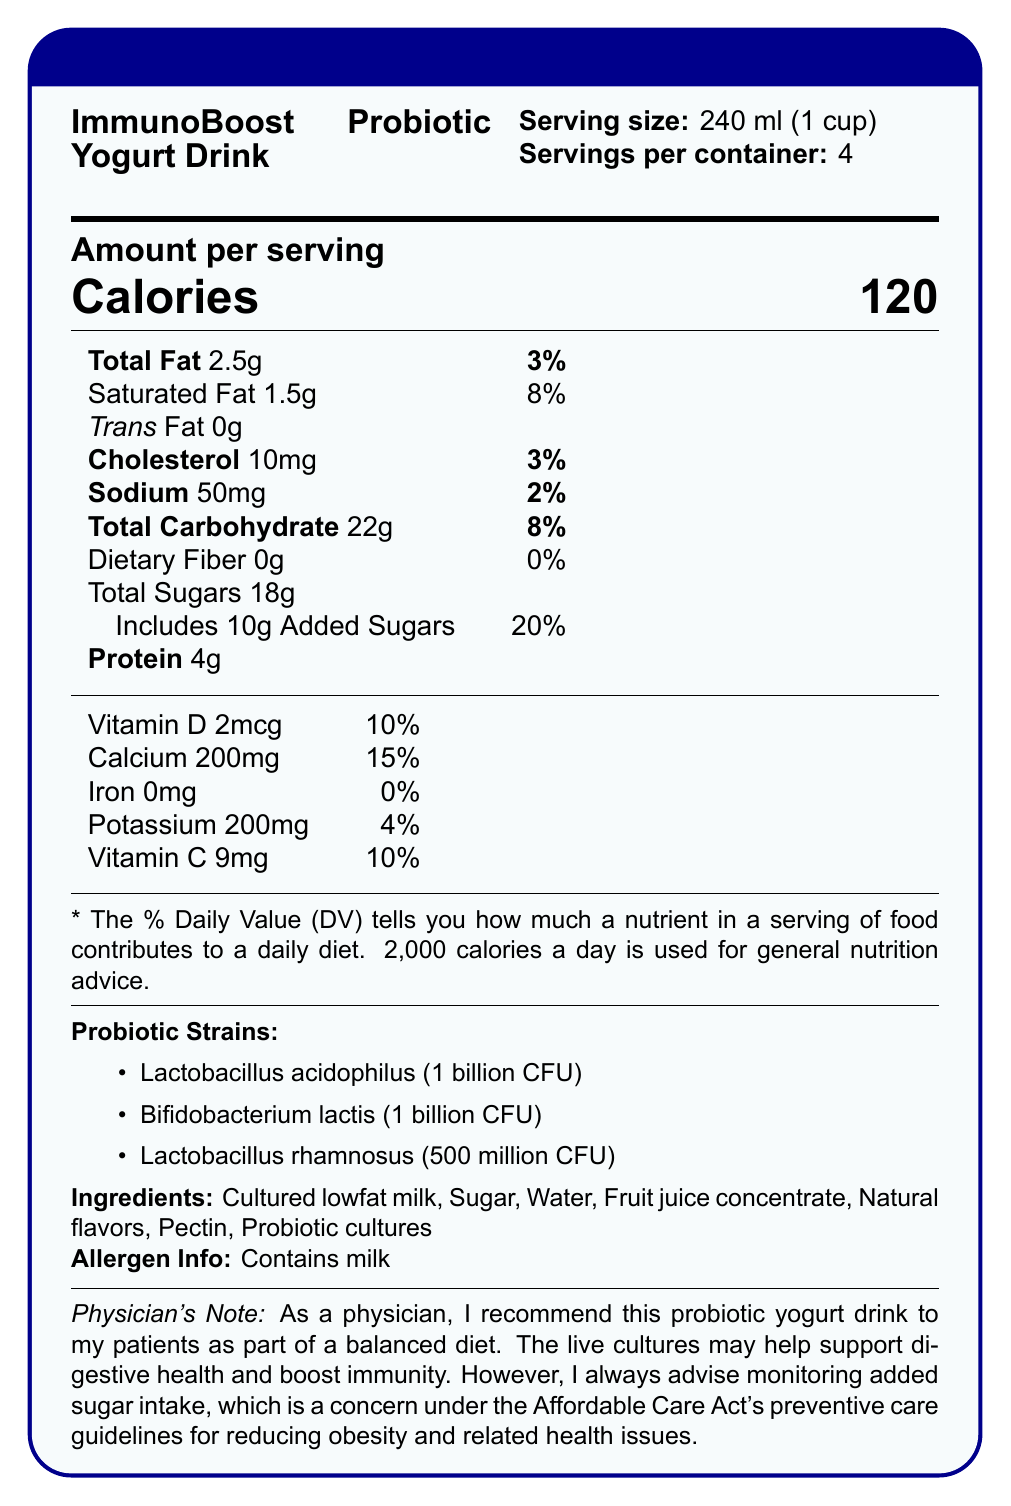what is the serving size of the ImmunoBoost Probiotic Yogurt Drink? The serving size is listed as 240 ml, which is equivalent to 1 cup.
Answer: 240 ml (1 cup) how many servings are there in one container? The label states that there are 4 servings per container.
Answer: 4 how many calories are in one serving of the yogurt drink? The label lists the calories per serving as 120.
Answer: 120 what is the total fat content per serving? The label indicates that the total fat content per serving is 2.5 grams.
Answer: 2.5g what is the percentage of daily value for added sugars per serving? The amount of added sugars in the yogurt drink is 10g, which is 20% of the daily value.
Answer: 20% which probiotic strain has the highest CFU count in the yogurt drink? A. Lactobacillus acidophilus B. Bifidobacterium lactis C. Lactobacillus rhamnosus Lactobacillus acidophilus and Bifidobacterium lactis both have 1 billion CFU, which is higher than the 500 million CFU of Lactobacillus rhamnosus. Lactobacillus acidophilus is the first listed, implying a higher or equal amount among listed strains.
Answer: A. Lactobacillus acidophilus what percentage of the daily value of calcium does one serving of this yogurt drink provide? A. 5% B. 10% C. 15% The document states that one serving provides 200mg of calcium, which is 15% of the daily value.
Answer: C. 15% does the product contain any dietary fiber? The nutritional information lists dietary fiber as 0g, implying the product contains no dietary fiber.
Answer: No is there an allergen warning present on the label? The label indicates that the yogurt drink contains milk, classified as an allergen.
Answer: Yes summarize the main nutritional benefits and concerns of the ImmunoBoost Probiotic Yogurt Drink. The document highlights the probiotic benefits of the yogurt drink, emphasizing its live cultures and nutrients while advising caution about its added sugar content.
Answer: The ImmunoBoost Probiotic Yogurt Drink provides beneficial live cultures that may support digestive health and boost immunity, with essential vitamins and minerals like calcium and vitamin D. However, it contains added sugars, which constitutes 20% of the daily value per serving, a concern for monitoring sugar intake. what is the main ingredient in the yogurt drink? The first ingredient listed is "Cultured lowfat milk," indicating it is the main ingredient.
Answer: Cultured lowfat milk how much protein does one serving contain? The protein content per serving is 4 grams as listed in the nutritional information.
Answer: 4g what is the physician's recommendation about the yogurt drink regarding diet? The document provides a note from a physician recommending the yogurt drink for digestive health and immunity while advising attention to its added sugar content.
Answer: The physician recommends the yogurt drink as part of a balanced diet and advises monitoring added sugar intake. which ingredient acts as the source of probiotics in the yogurt drink? The term "Probiotic cultures" listed in the ingredients is the source of probiotics.
Answer: Probiotic cultures what is the primary health benefit mentioned by the physician for this yogurt drink? The physician mentions that the live cultures in the yogurt may help support digestive health and boost immunity.
Answer: Supporting digestive health and boosting immunity is there any iron content in the yogurt drink according to the label? The label indicates 0mg of iron per serving, showing there is no iron content.
Answer: No can you tell how much cholesterol is in one serving of the yogurt drink? The nutrition facts label specifies that there are 10 milligrams of cholesterol per serving.
Answer: 10mg what is the total carbohydrate content per serving? The total amount of carbohydrates per serving is 22 grams, as listed in the document.
Answer: 22g which of the following probiotic strains is present in the smallest amount in the yogurt drink? A. Lactobacillus acidophilus B. Bifidobacterium lactis C. Lactobacillus rhamnosus Lactobacillus rhamnosus has 500 million CFU, which is less than the 1 billion CFU of the other strains listed.
Answer: C. Lactobacillus rhamnosus can the information provided determine how much fruit juice concentrate is in the yogurt drink? The document lists "Fruit juice concentrate" among the ingredients but does not specify the amount.
Answer: Cannot be determined 